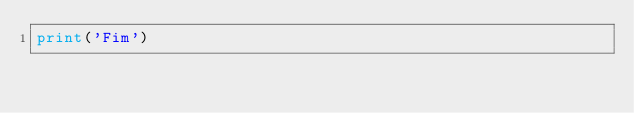<code> <loc_0><loc_0><loc_500><loc_500><_Python_>print('Fim')</code> 